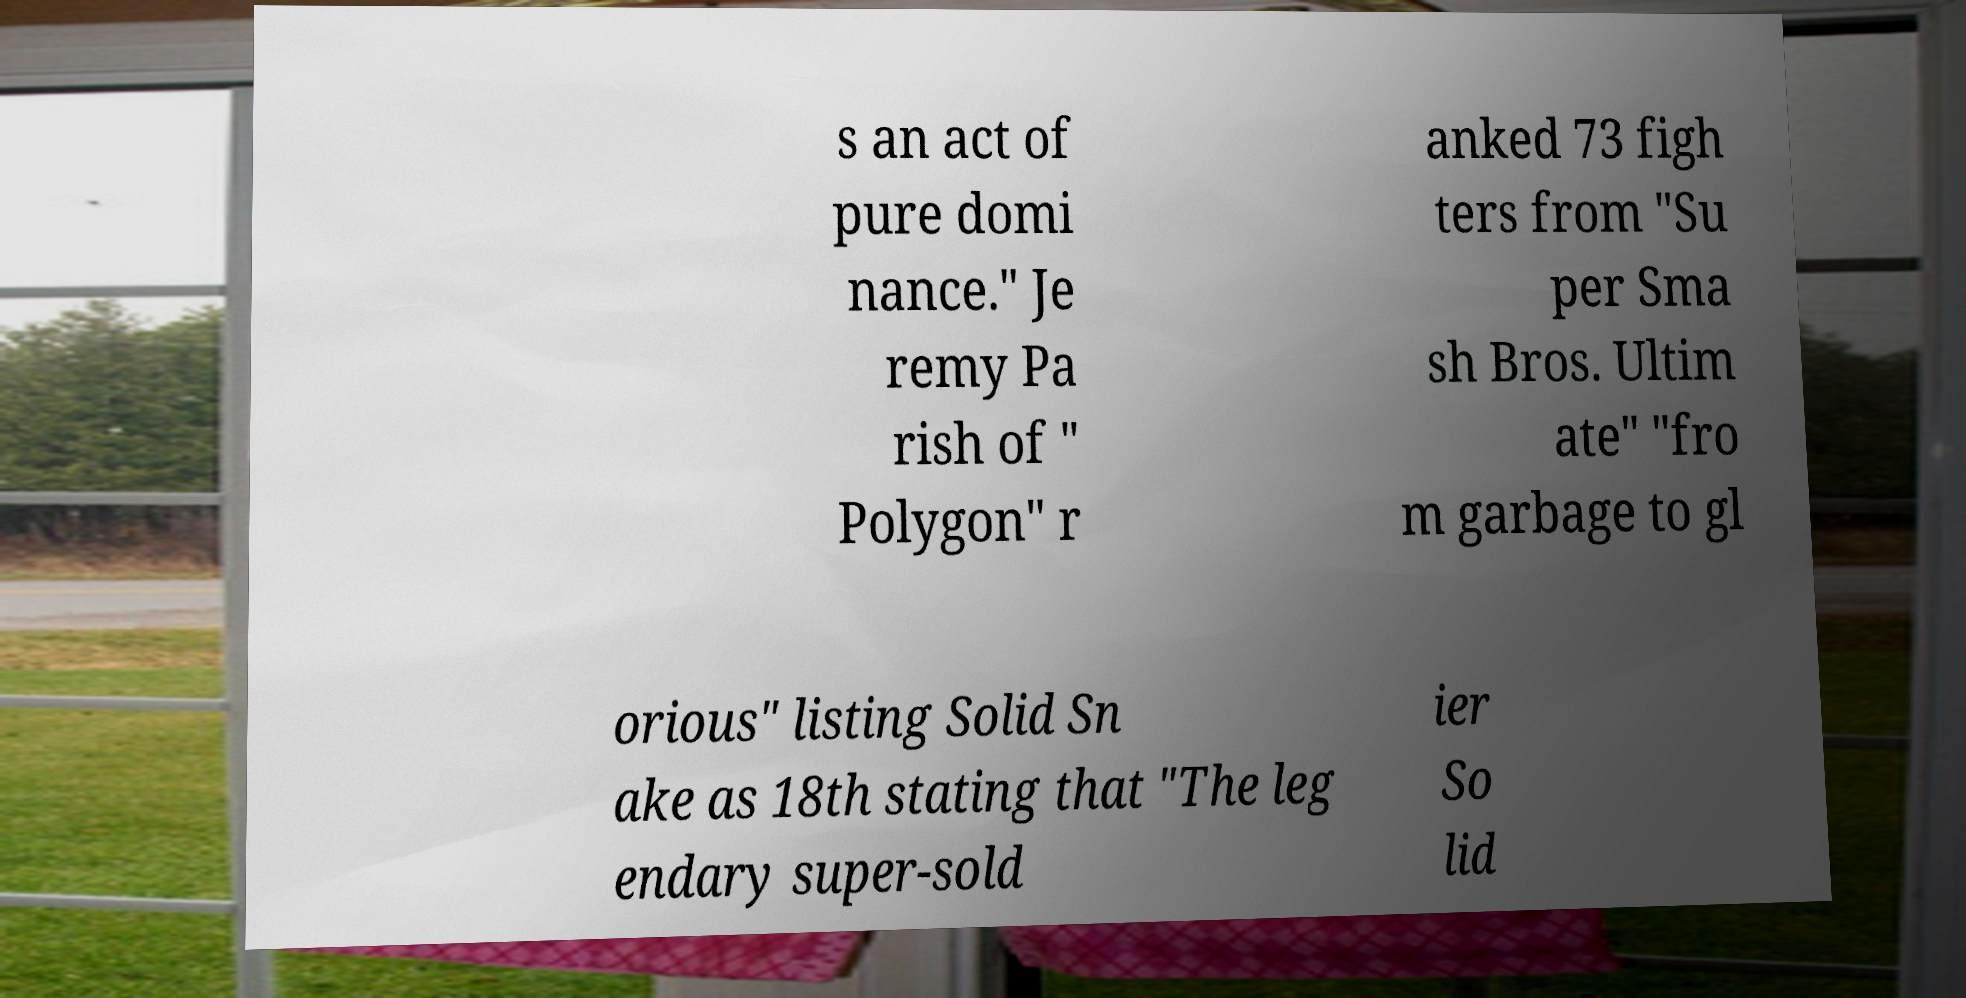Can you read and provide the text displayed in the image?This photo seems to have some interesting text. Can you extract and type it out for me? s an act of pure domi nance." Je remy Pa rish of " Polygon" r anked 73 figh ters from "Su per Sma sh Bros. Ultim ate" "fro m garbage to gl orious" listing Solid Sn ake as 18th stating that "The leg endary super-sold ier So lid 